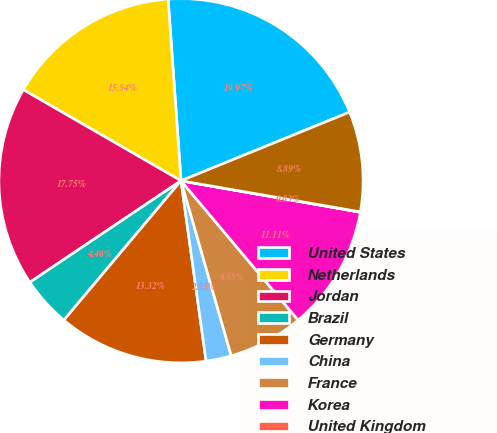<chart> <loc_0><loc_0><loc_500><loc_500><pie_chart><fcel>United States<fcel>Netherlands<fcel>Jordan<fcel>Brazil<fcel>Germany<fcel>China<fcel>France<fcel>Korea<fcel>United Kingdom<fcel>Other foreign countries<nl><fcel>19.97%<fcel>15.54%<fcel>17.75%<fcel>4.46%<fcel>13.32%<fcel>2.25%<fcel>6.68%<fcel>11.11%<fcel>0.03%<fcel>8.89%<nl></chart> 